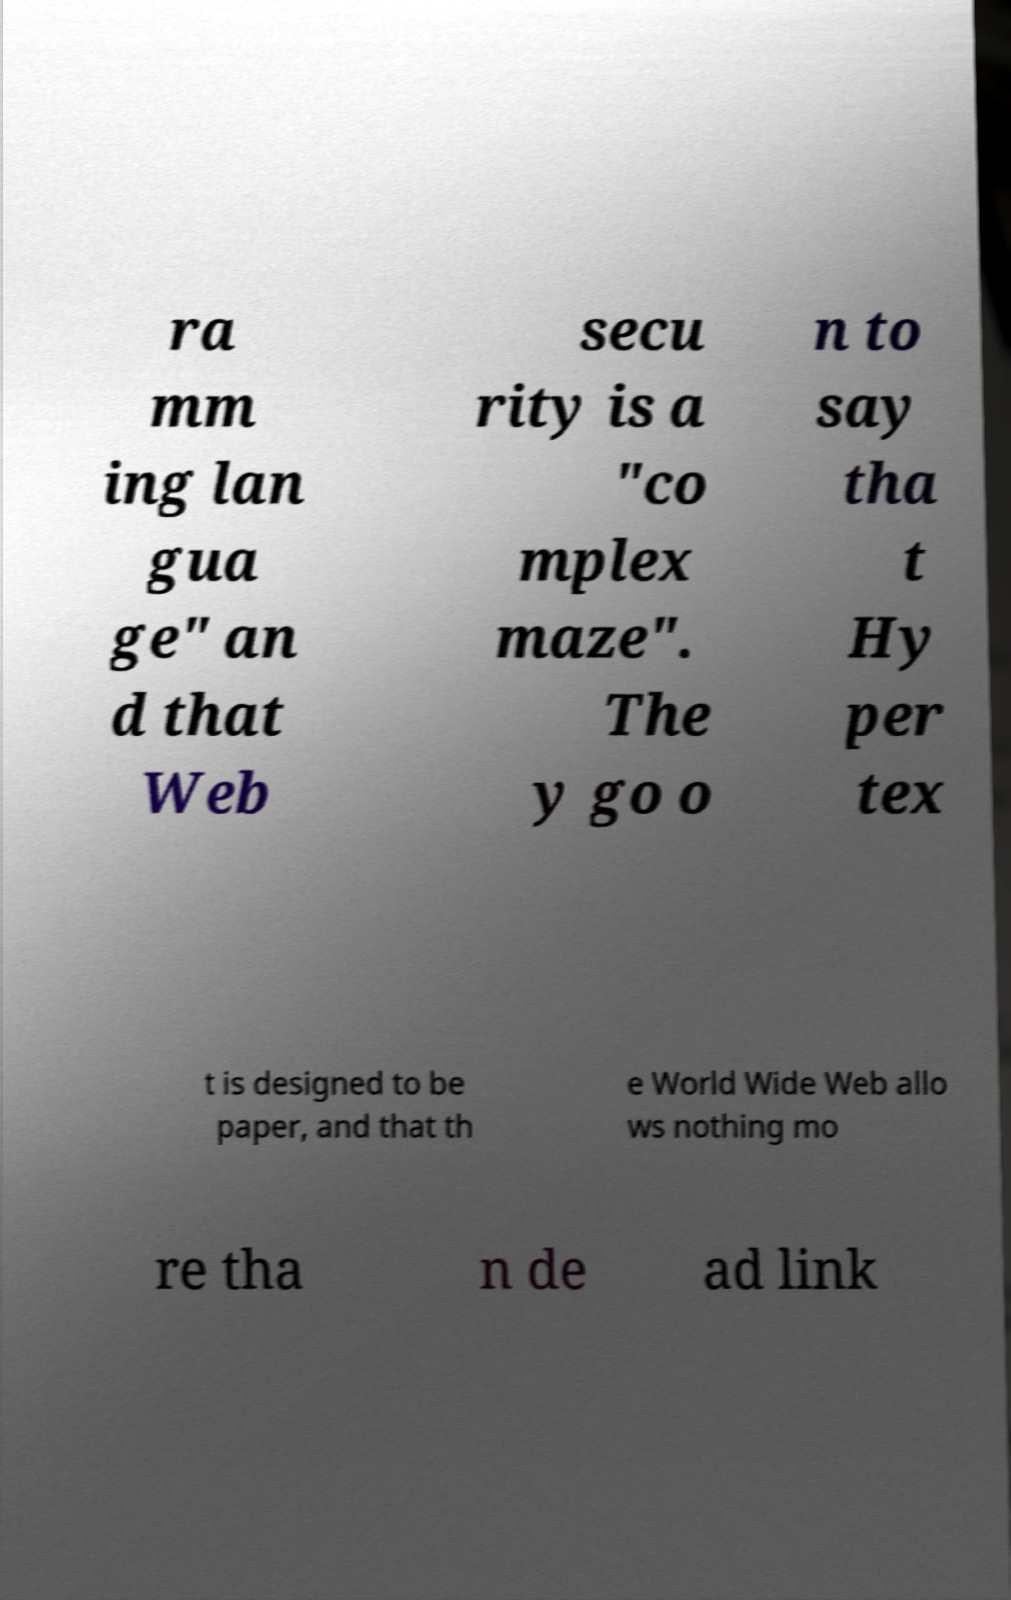Please identify and transcribe the text found in this image. ra mm ing lan gua ge" an d that Web secu rity is a ″co mplex maze″. The y go o n to say tha t Hy per tex t is designed to be paper, and that th e World Wide Web allo ws nothing mo re tha n de ad link 